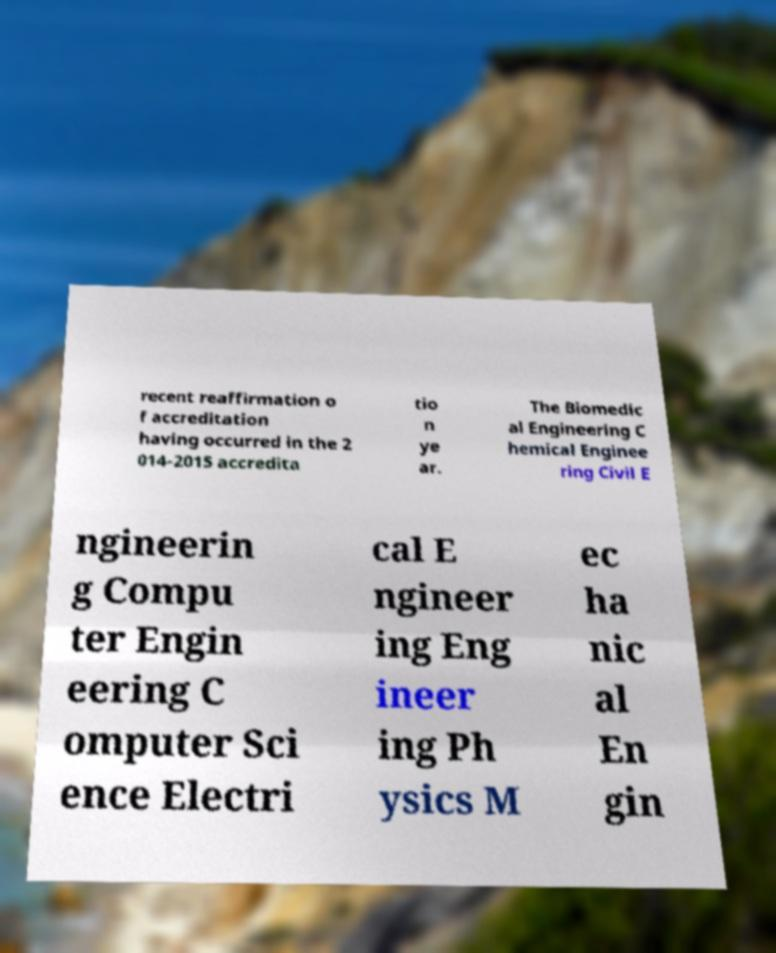I need the written content from this picture converted into text. Can you do that? recent reaffirmation o f accreditation having occurred in the 2 014-2015 accredita tio n ye ar. The Biomedic al Engineering C hemical Enginee ring Civil E ngineerin g Compu ter Engin eering C omputer Sci ence Electri cal E ngineer ing Eng ineer ing Ph ysics M ec ha nic al En gin 